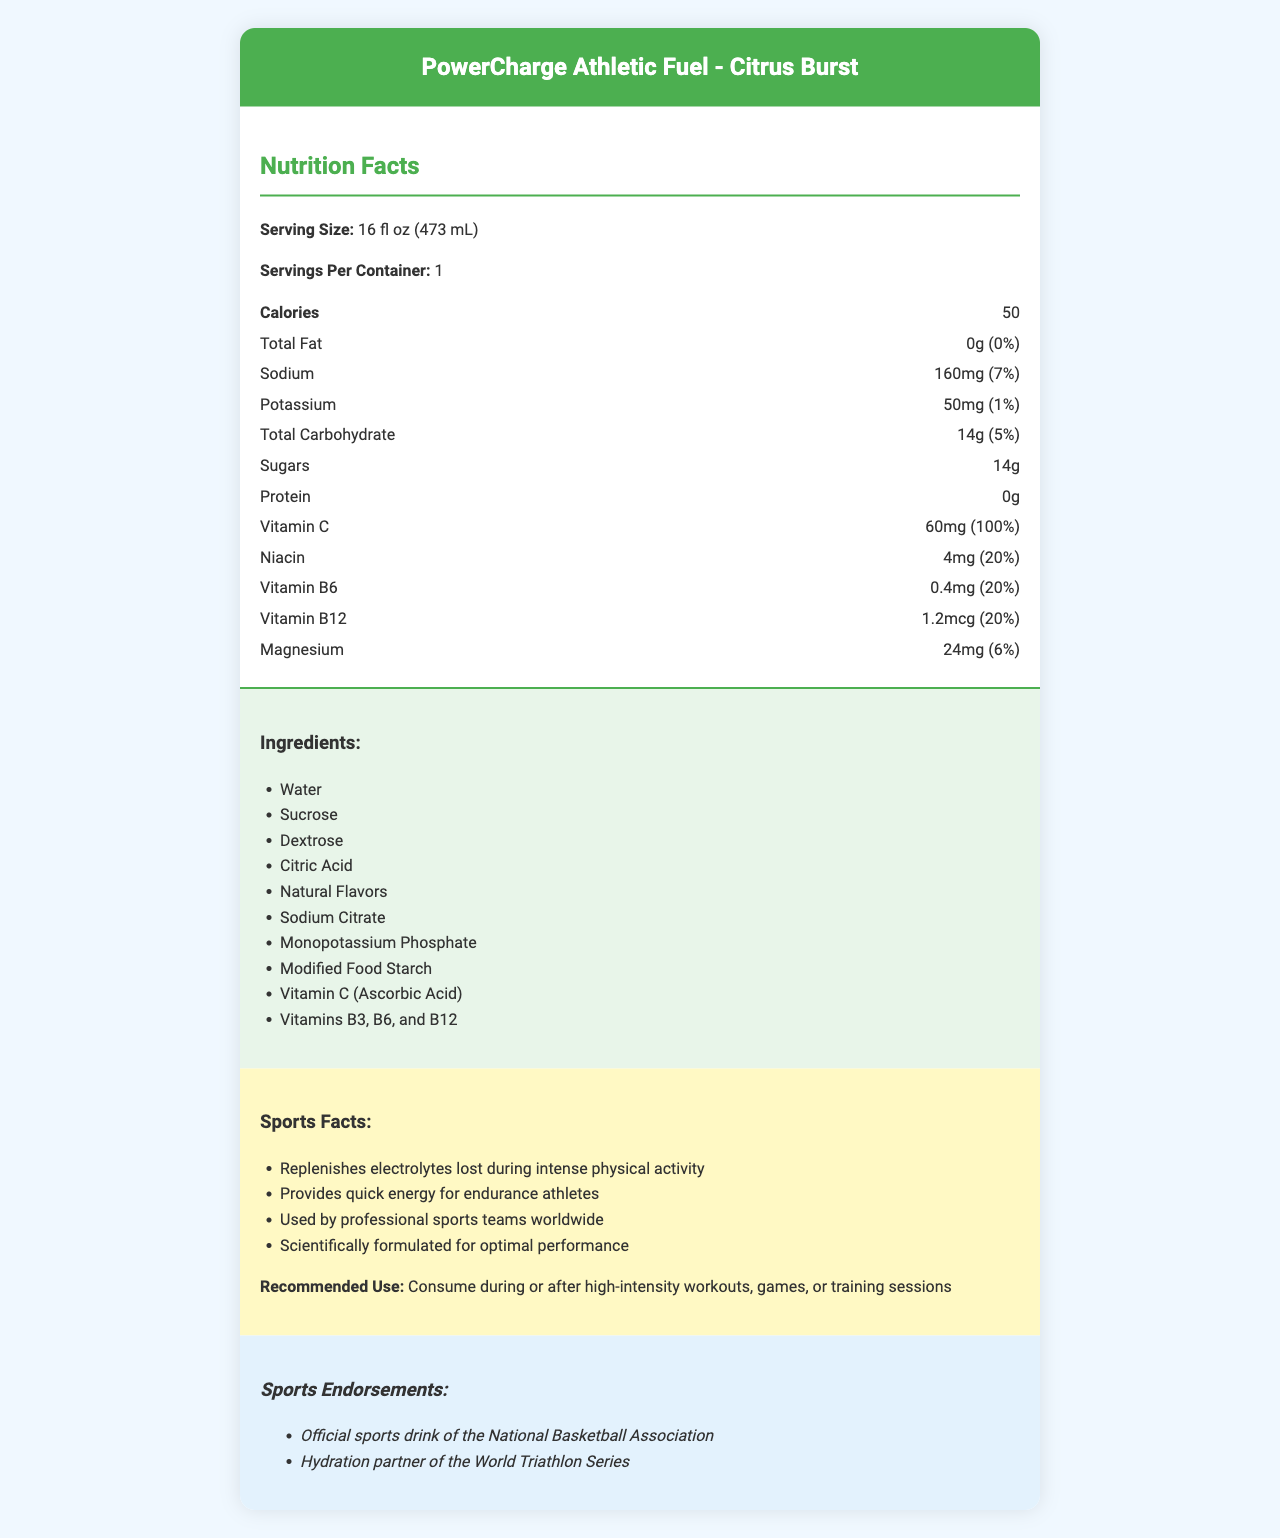what is the serving size of PowerCharge Athletic Fuel? The serving size is directly listed in the nutrition facts section at the beginning of the document.
Answer: 16 fl oz (473 mL) how many calories are in one serving of PowerCharge Athletic Fuel? The calories are specified under the nutrition facts section.
Answer: 50 calories what is the amount of sodium in one serving? The nutrition facts show the amount of sodium is 160mg.
Answer: 160mg how much Vitamin C does one serving provide? The nutrition facts indicate that one serving provides 60mg of Vitamin C.
Answer: 60mg what is PowerCharge Athletic Fuel recommended for? The recommended use is noted in the sports facts section.
Answer: Consume during or after high-intensity workouts, games, or training sessions Which vitamin has a daily value percentage of 100% in PowerCharge Athletic Fuel? A. Vitamin B12 B. Niacin C. Vitamin C The Vitamin C daily value percentage is shown to be 100% in the nutrition facts section.
Answer: C. Vitamin C What is the daily value percentage of Sodium in one serving of PowerCharge Athletic Fuel? A. 5% B. 7% C. 10% D. 15% The sodium daily value percentage is provided as 7% in the nutrition facts section.
Answer: B. 7% How much total carbohydrate is in a serving? A. 10g B. 12g C. 14g D. 16g The total carbohydrate amount is listed as 14g in the nutrition facts section.
Answer: C. 14g Is PowerCharge Athletic Fuel endorsed by the National Basketball Association? The endorsements section specifically mentions that it is the official sports drink of the National Basketball Association.
Answer: Yes Does PowerCharge Athletic Fuel contain protein? In the nutrition facts, it is mentioned that there is 0g of protein in the drink.
Answer: No summarize the main idea of this document This summary captures the primary information provided by the document, touching on all key sections and their contents.
Answer: The document is a detailed description of the nutrition facts for PowerCharge Athletic Fuel. It includes the serving size, calorie content, amounts of various nutrients, a list of ingredients, sports performance benefits, usage recommendations, and sports endorsements. What is the source of dextrose in the ingredients list? The document lists dextrose as an ingredient but does not provide the source of the dextrose.
Answer: Not enough information 